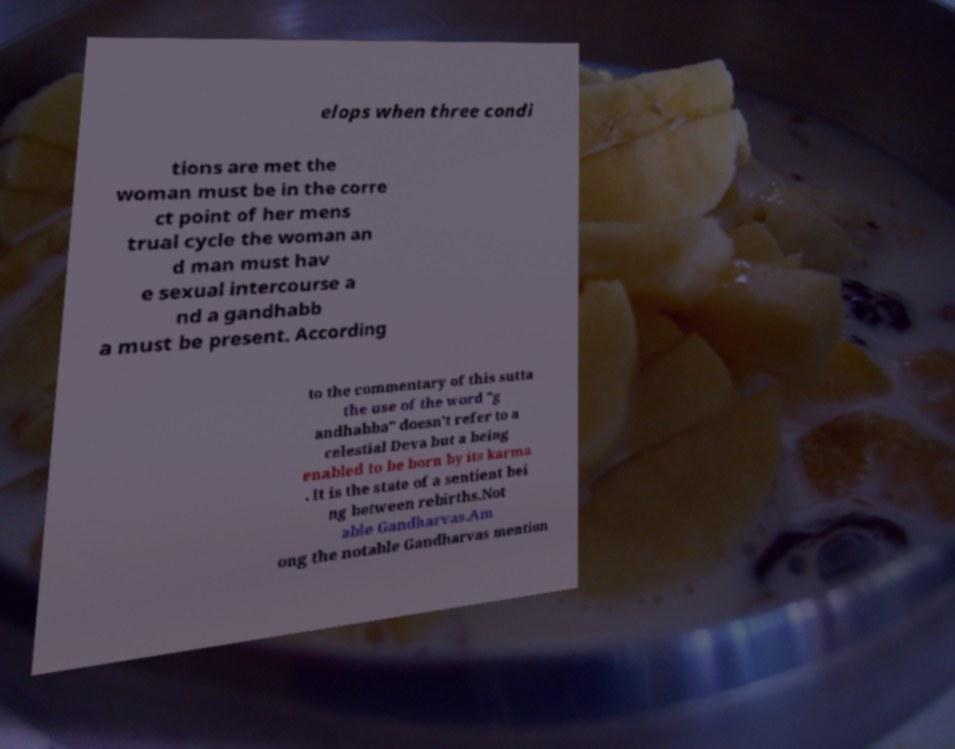Please identify and transcribe the text found in this image. elops when three condi tions are met the woman must be in the corre ct point of her mens trual cycle the woman an d man must hav e sexual intercourse a nd a gandhabb a must be present. According to the commentary of this sutta the use of the word "g andhabba" doesn't refer to a celestial Deva but a being enabled to be born by its karma . It is the state of a sentient bei ng between rebirths.Not able Gandharvas.Am ong the notable Gandharvas mention 